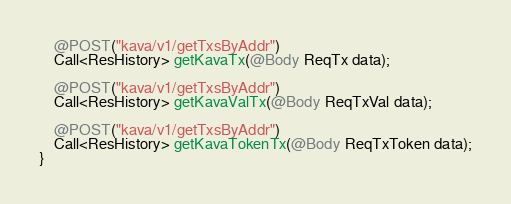<code> <loc_0><loc_0><loc_500><loc_500><_Java_>
    @POST("kava/v1/getTxsByAddr")
    Call<ResHistory> getKavaTx(@Body ReqTx data);

    @POST("kava/v1/getTxsByAddr")
    Call<ResHistory> getKavaValTx(@Body ReqTxVal data);

    @POST("kava/v1/getTxsByAddr")
    Call<ResHistory> getKavaTokenTx(@Body ReqTxToken data);
}
</code> 